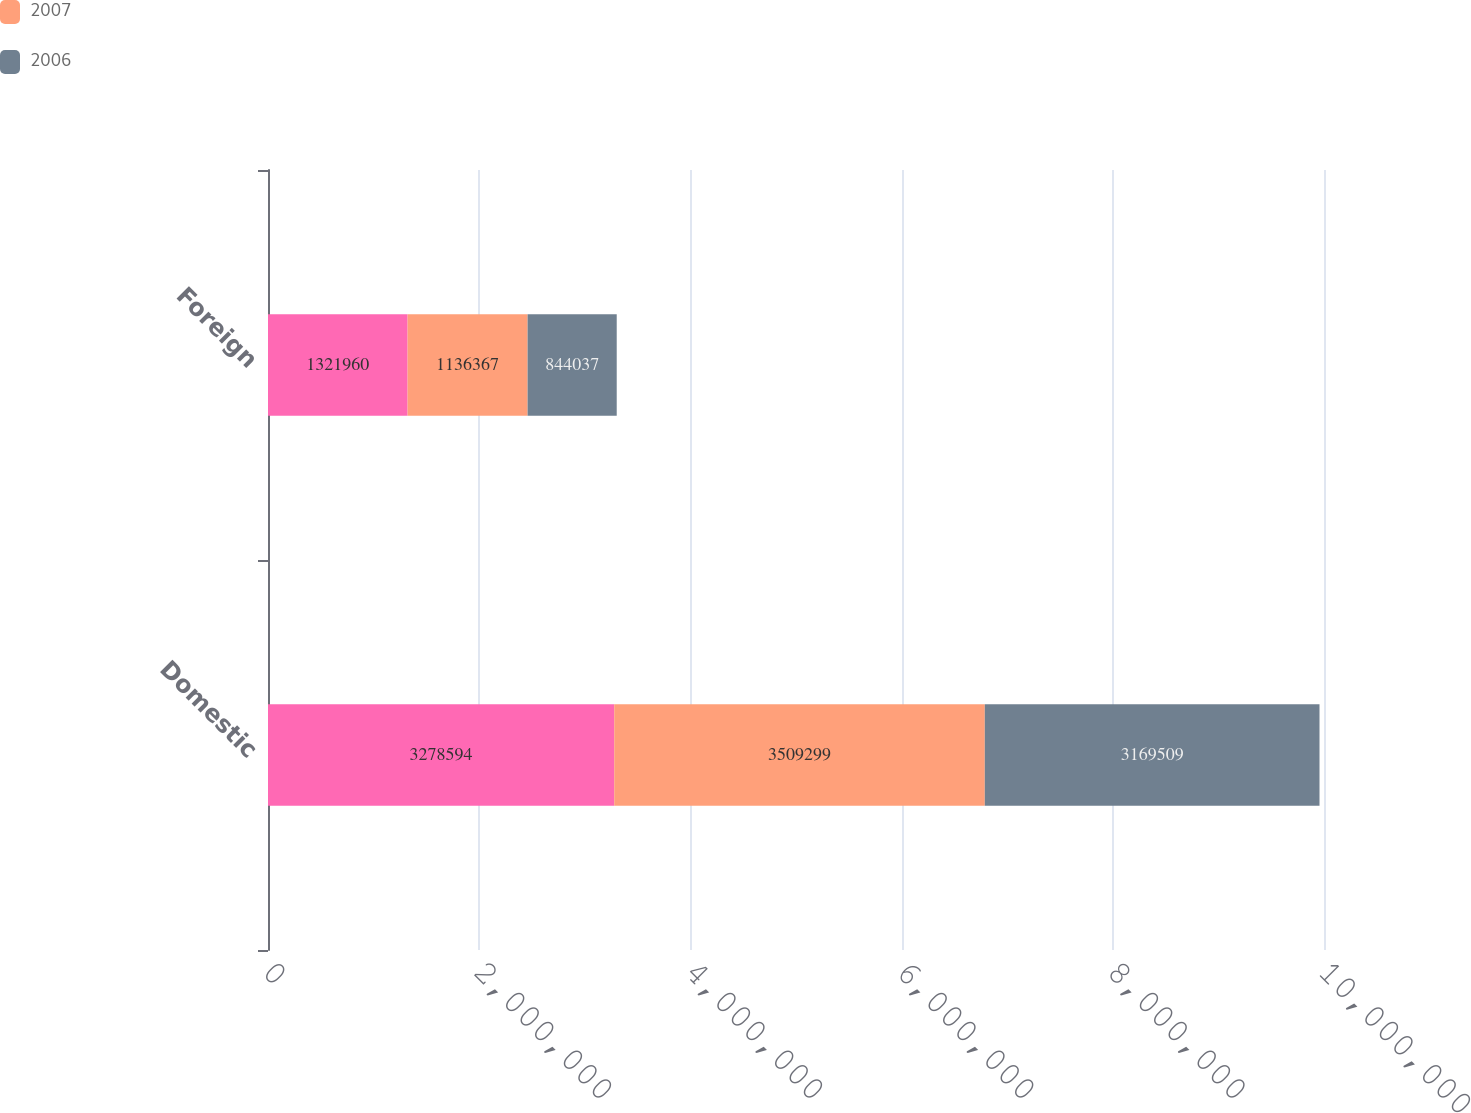<chart> <loc_0><loc_0><loc_500><loc_500><stacked_bar_chart><ecel><fcel>Domestic<fcel>Foreign<nl><fcel>nan<fcel>3.27859e+06<fcel>1.32196e+06<nl><fcel>2007<fcel>3.5093e+06<fcel>1.13637e+06<nl><fcel>2006<fcel>3.16951e+06<fcel>844037<nl></chart> 